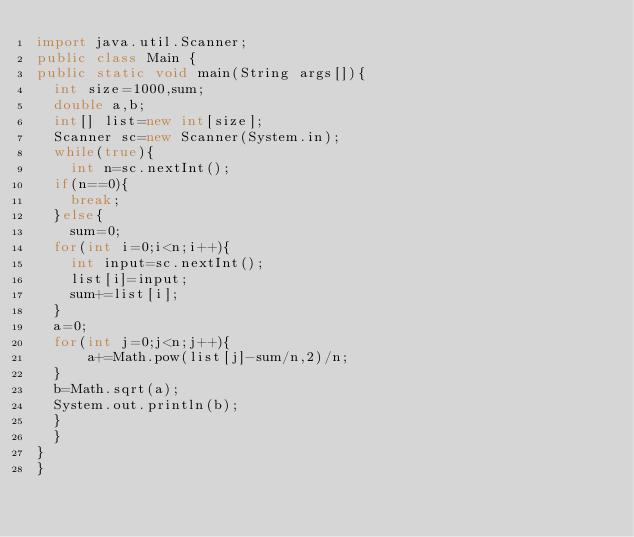Convert code to text. <code><loc_0><loc_0><loc_500><loc_500><_Java_>import java.util.Scanner;
public class Main {
public static void main(String args[]){
	int size=1000,sum;
	double a,b;
	int[] list=new int[size];
	Scanner sc=new Scanner(System.in);
	while(true){
		int n=sc.nextInt();
	if(n==0){
		break;
	}else{
		sum=0;
	for(int i=0;i<n;i++){
		int input=sc.nextInt();
		list[i]=input;
		sum+=list[i];
	}
	a=0;
	for(int j=0;j<n;j++){
	    a+=Math.pow(list[j]-sum/n,2)/n;
	}
	b=Math.sqrt(a);
	System.out.println(b);
	}
	}
}
}</code> 